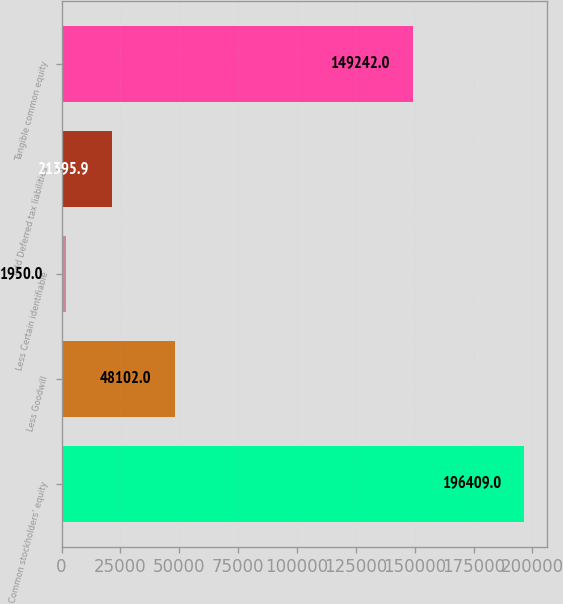Convert chart to OTSL. <chart><loc_0><loc_0><loc_500><loc_500><bar_chart><fcel>Common stockholders' equity<fcel>Less Goodwill<fcel>Less Certain identifiable<fcel>Add Deferred tax liabilities<fcel>Tangible common equity<nl><fcel>196409<fcel>48102<fcel>1950<fcel>21395.9<fcel>149242<nl></chart> 